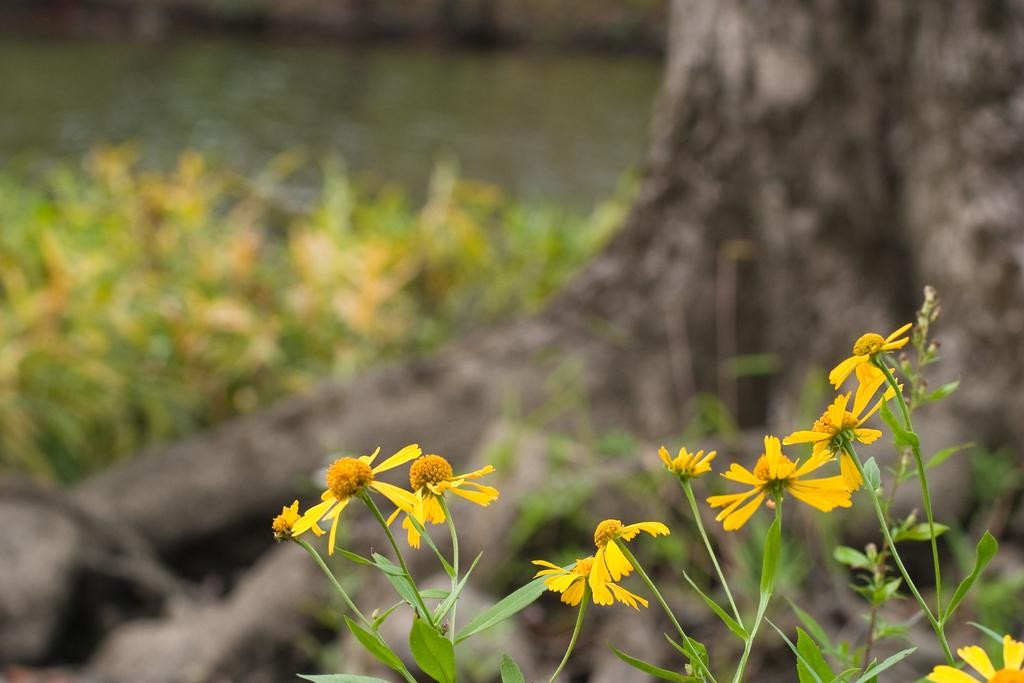What type of flowers are present in the image? There are small yellow flowers in the image. What color are the stalks of the flowers? The stalks of the flowers are green. What else can be seen on the flowers besides the petals? The flowers have green leaves. What type of veil is draped over the flowers in the image? There is no veil present in the image; the flowers are not covered or draped. 